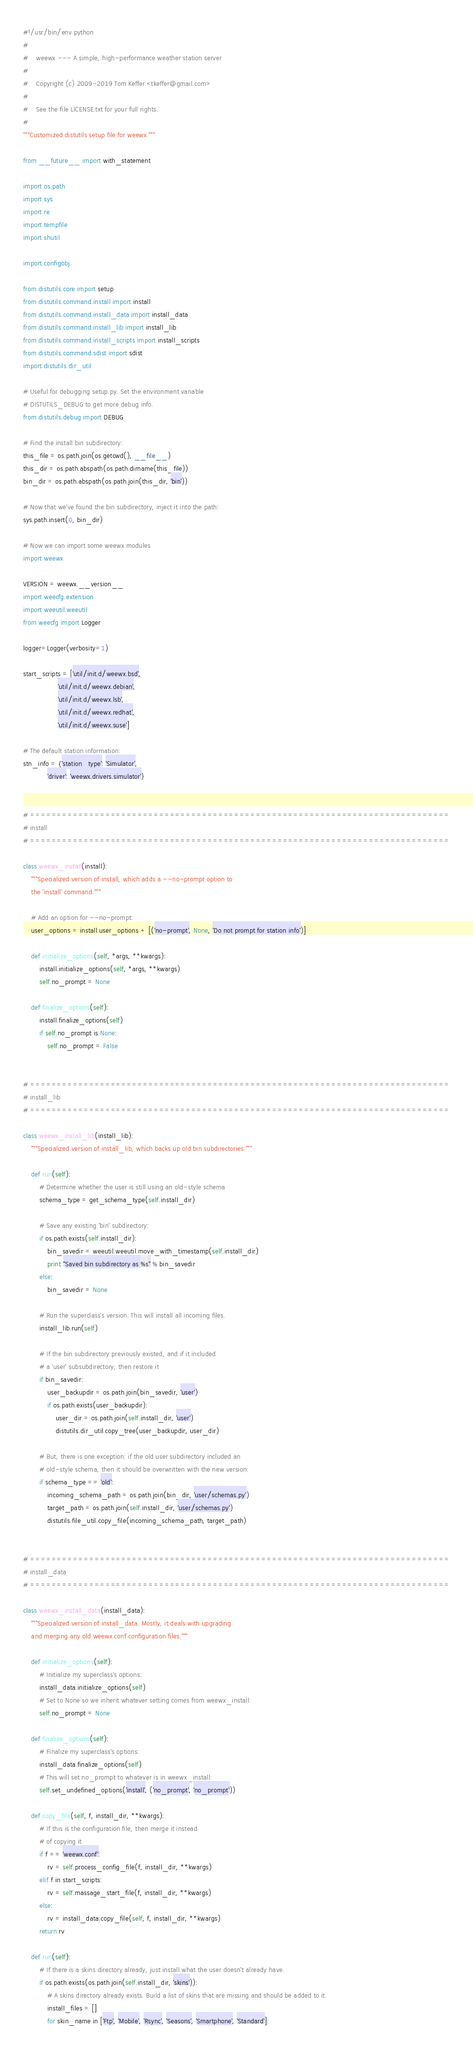Convert code to text. <code><loc_0><loc_0><loc_500><loc_500><_Python_>#!/usr/bin/env python
#
#    weewx --- A simple, high-performance weather station server
#
#    Copyright (c) 2009-2019 Tom Keffer <tkeffer@gmail.com>
#
#    See the file LICENSE.txt for your full rights.
#
"""Customized distutils setup file for weewx."""

from __future__ import with_statement

import os.path
import sys
import re
import tempfile
import shutil

import configobj

from distutils.core import setup
from distutils.command.install import install
from distutils.command.install_data import install_data
from distutils.command.install_lib import install_lib
from distutils.command.install_scripts import install_scripts
from distutils.command.sdist import sdist
import distutils.dir_util

# Useful for debugging setup.py. Set the environment variable
# DISTUTILS_DEBUG to get more debug info.
from distutils.debug import DEBUG

# Find the install bin subdirectory:
this_file = os.path.join(os.getcwd(), __file__)
this_dir = os.path.abspath(os.path.dirname(this_file))
bin_dir = os.path.abspath(os.path.join(this_dir, 'bin'))

# Now that we've found the bin subdirectory, inject it into the path:
sys.path.insert(0, bin_dir)

# Now we can import some weewx modules
import weewx

VERSION = weewx.__version__
import weecfg.extension
import weeutil.weeutil
from weecfg import Logger

logger=Logger(verbosity=1)

start_scripts = ['util/init.d/weewx.bsd',
                 'util/init.d/weewx.debian',
                 'util/init.d/weewx.lsb',
                 'util/init.d/weewx.redhat',
                 'util/init.d/weewx.suse']

# The default station information:
stn_info = {'station_type': 'Simulator',
            'driver': 'weewx.drivers.simulator'}


# ==============================================================================
# install
# ==============================================================================

class weewx_install(install):
    """Specialized version of install, which adds a --no-prompt option to
    the 'install' command."""

    # Add an option for --no-prompt:
    user_options = install.user_options + [('no-prompt', None, 'Do not prompt for station info')]

    def initialize_options(self, *args, **kwargs):
        install.initialize_options(self, *args, **kwargs)
        self.no_prompt = None

    def finalize_options(self):
        install.finalize_options(self)
        if self.no_prompt is None:
            self.no_prompt = False


# ==============================================================================
# install_lib
# ==============================================================================

class weewx_install_lib(install_lib):
    """Specialized version of install_lib, which backs up old bin subdirectories."""

    def run(self):
        # Determine whether the user is still using an old-style schema
        schema_type = get_schema_type(self.install_dir)

        # Save any existing 'bin' subdirectory:
        if os.path.exists(self.install_dir):
            bin_savedir = weeutil.weeutil.move_with_timestamp(self.install_dir)
            print "Saved bin subdirectory as %s" % bin_savedir
        else:
            bin_savedir = None

        # Run the superclass's version. This will install all incoming files.
        install_lib.run(self)

        # If the bin subdirectory previously existed, and if it included
        # a 'user' subsubdirectory, then restore it
        if bin_savedir:
            user_backupdir = os.path.join(bin_savedir, 'user')
            if os.path.exists(user_backupdir):
                user_dir = os.path.join(self.install_dir, 'user')
                distutils.dir_util.copy_tree(user_backupdir, user_dir)

        # But, there is one exception: if the old user subdirectory included an
        # old-style schema, then it should be overwritten with the new version.
        if schema_type == 'old':
            incoming_schema_path = os.path.join(bin_dir, 'user/schemas.py')
            target_path = os.path.join(self.install_dir, 'user/schemas.py')
            distutils.file_util.copy_file(incoming_schema_path, target_path)


# ==============================================================================
# install_data
# ==============================================================================

class weewx_install_data(install_data):
    """Specialized version of install_data. Mostly, it deals with upgrading
    and merging any old weewx.conf configuration files."""

    def initialize_options(self):
        # Initialize my superclass's options:
        install_data.initialize_options(self)
        # Set to None so we inherit whatever setting comes from weewx_install:
        self.no_prompt = None

    def finalize_options(self):
        # Finalize my superclass's options:
        install_data.finalize_options(self)
        # This will set no_prompt to whatever is in weewx_install:
        self.set_undefined_options('install', ('no_prompt', 'no_prompt'))

    def copy_file(self, f, install_dir, **kwargs):
        # If this is the configuration file, then merge it instead
        # of copying it
        if f == 'weewx.conf':
            rv = self.process_config_file(f, install_dir, **kwargs)
        elif f in start_scripts:
            rv = self.massage_start_file(f, install_dir, **kwargs)
        else:
            rv = install_data.copy_file(self, f, install_dir, **kwargs)
        return rv

    def run(self):
        # If there is a skins directory already, just install what the user doesn't already have.
        if os.path.exists(os.path.join(self.install_dir, 'skins')):
            # A skins directory already exists. Build a list of skins that are missing and should be added to it.
            install_files = []
            for skin_name in ['Ftp', 'Mobile', 'Rsync', 'Seasons', 'Smartphone', 'Standard']:</code> 